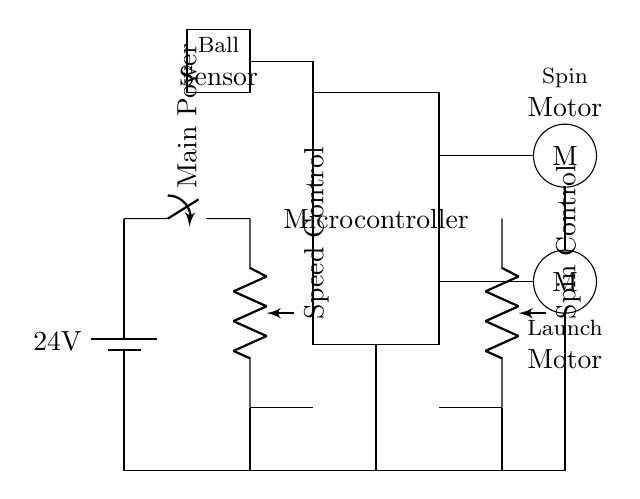What is the operating voltage of this circuit? The circuit operates at 24 volts, represented by the battery in the diagram.
Answer: 24 volts What components are present in this circuit? The circuit includes a microcontroller, two potentiometers for speed and spin control, two DC motors, and a ball sensor.
Answer: Microcontroller, potentiometers, DC motors, ball sensor How many motors are used in this circuit? There are two motors in this circuit—one for launching the ball and another for spin control.
Answer: Two What is the function of the speed control potentiometer? The speed control potentiometer adjusts the speed of the launch motor by varying the resistance in the circuit.
Answer: Adjust speed Explain the role of the ball sensor in the circuit. The ball sensor detects the presence of a ball; it is critical for triggering the launch sequence when a ball is detected, ensuring proper timing.
Answer: Detects ball What components are connected to the spin control potentiometer? The spin control potentiometer is connected to the spin motor, allowing adjustment of the motor's speed.
Answer: Spin motor What are the two types of motors in the circuit? The circuit features a launch motor for ball launching and a spin motor for imparting spin to the ball.
Answer: Launch and spin motors 